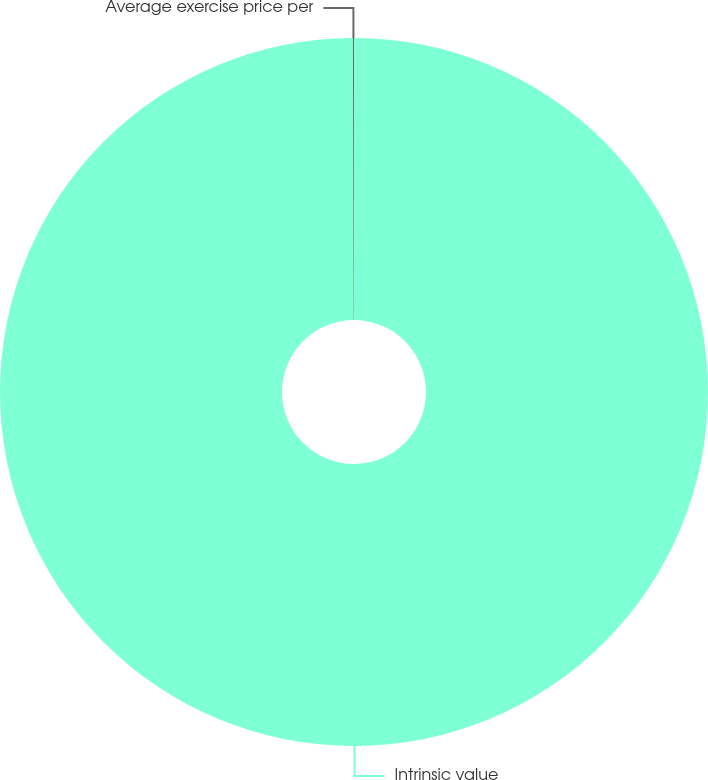<chart> <loc_0><loc_0><loc_500><loc_500><pie_chart><fcel>Intrinsic value<fcel>Average exercise price per<nl><fcel>99.95%<fcel>0.05%<nl></chart> 